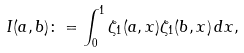Convert formula to latex. <formula><loc_0><loc_0><loc_500><loc_500>I ( a , b ) \colon = \int _ { 0 } ^ { 1 } \zeta _ { 1 } ( a , x ) \zeta _ { 1 } ( b , x ) \, d x ,</formula> 